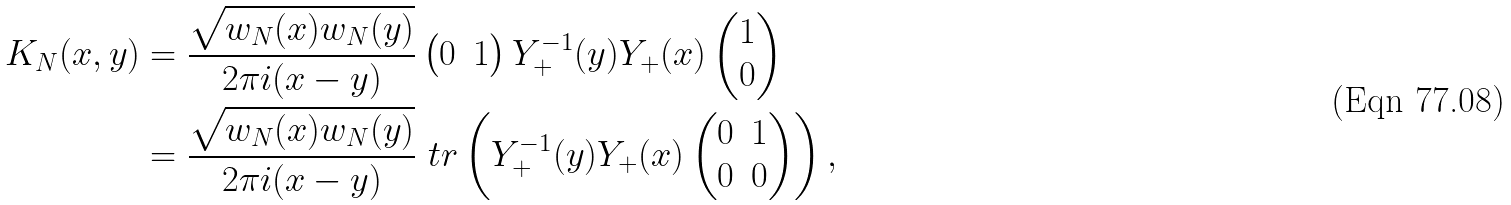<formula> <loc_0><loc_0><loc_500><loc_500>K _ { N } ( x , y ) & = \frac { \sqrt { w _ { N } ( x ) w _ { N } ( y ) } } { 2 \pi i ( x - y ) } \begin{pmatrix} 0 & 1 \end{pmatrix} Y _ { + } ^ { - 1 } ( y ) Y _ { + } ( x ) \begin{pmatrix} 1 \\ 0 \end{pmatrix} \\ & = \frac { \sqrt { w _ { N } ( x ) w _ { N } ( y ) } } { 2 \pi i ( x - y ) } \ t r \left ( Y _ { + } ^ { - 1 } ( y ) Y _ { + } ( x ) \begin{pmatrix} 0 & 1 \\ 0 & 0 \end{pmatrix} \right ) ,</formula> 